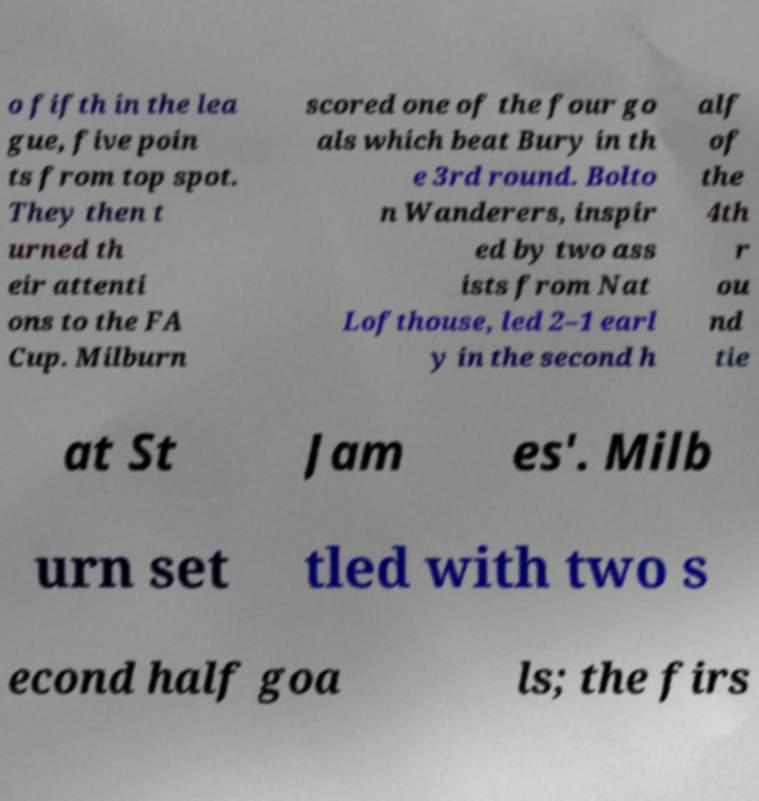Could you assist in decoding the text presented in this image and type it out clearly? o fifth in the lea gue, five poin ts from top spot. They then t urned th eir attenti ons to the FA Cup. Milburn scored one of the four go als which beat Bury in th e 3rd round. Bolto n Wanderers, inspir ed by two ass ists from Nat Lofthouse, led 2–1 earl y in the second h alf of the 4th r ou nd tie at St Jam es'. Milb urn set tled with two s econd half goa ls; the firs 